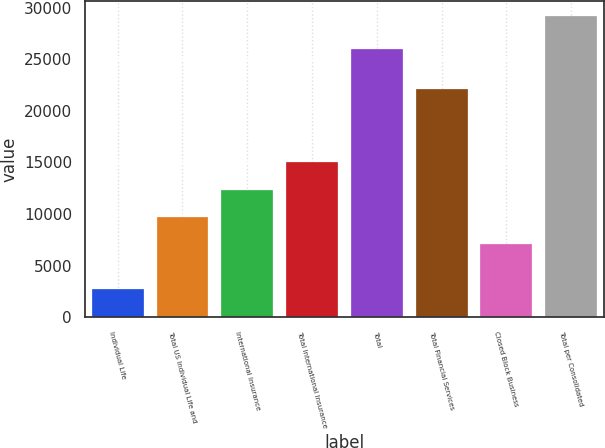<chart> <loc_0><loc_0><loc_500><loc_500><bar_chart><fcel>Individual Life<fcel>Total US Individual Life and<fcel>International Insurance<fcel>Total International Insurance<fcel>Total<fcel>Total Financial Services<fcel>Closed Block Business<fcel>Total per Consolidated<nl><fcel>2754<fcel>9705.5<fcel>12352<fcel>14998.5<fcel>25988<fcel>22160<fcel>7059<fcel>29219<nl></chart> 